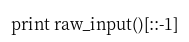Convert code to text. <code><loc_0><loc_0><loc_500><loc_500><_Python_>print raw_input()[::-1]</code> 